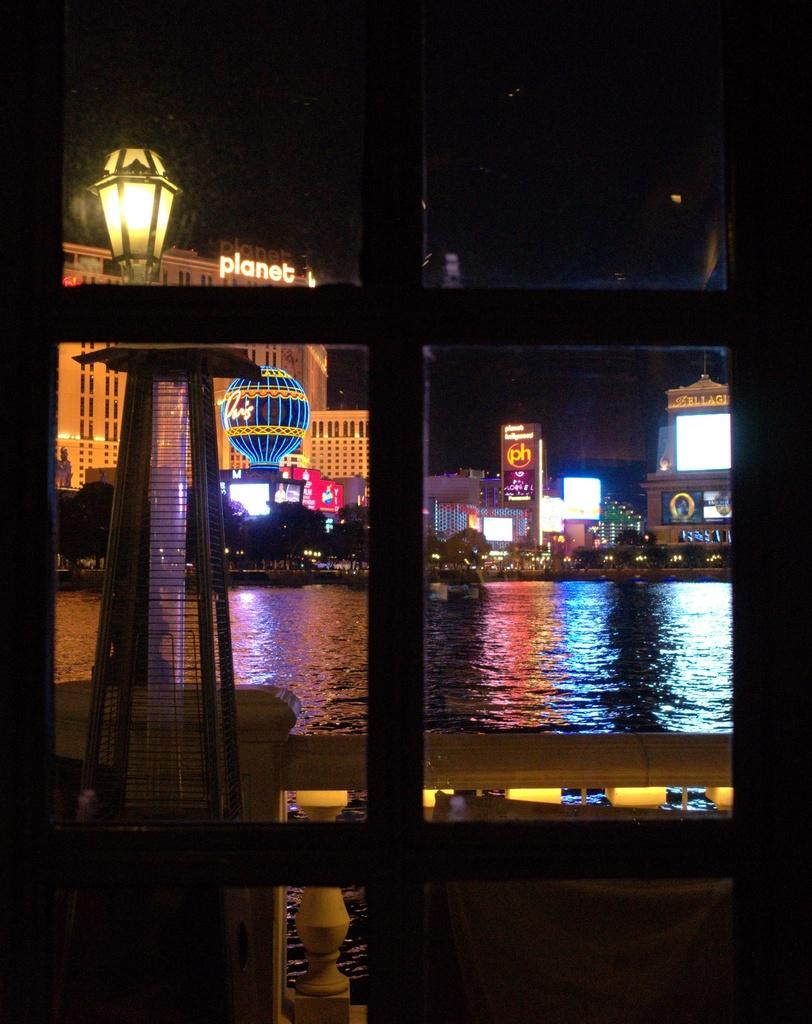What is visible in the image? Water, buildings, hoardings, and lights are visible in the image. Can you describe the buildings in the image? There are buildings in the image, but their specific characteristics are not mentioned in the provided facts. What type of advertisements might be displayed on the hoardings in the image? The content of the advertisements on the hoardings is not mentioned in the provided facts. What is the purpose of the lights in the image? The purpose of the lights in the image is not mentioned in the provided facts. What type of insect can be seen crawling on the side of the building in the image? There is no insect present in the image. Is it raining in the image? The provided facts do not mention any weather conditions, so it cannot be determined if it is raining in the image. 